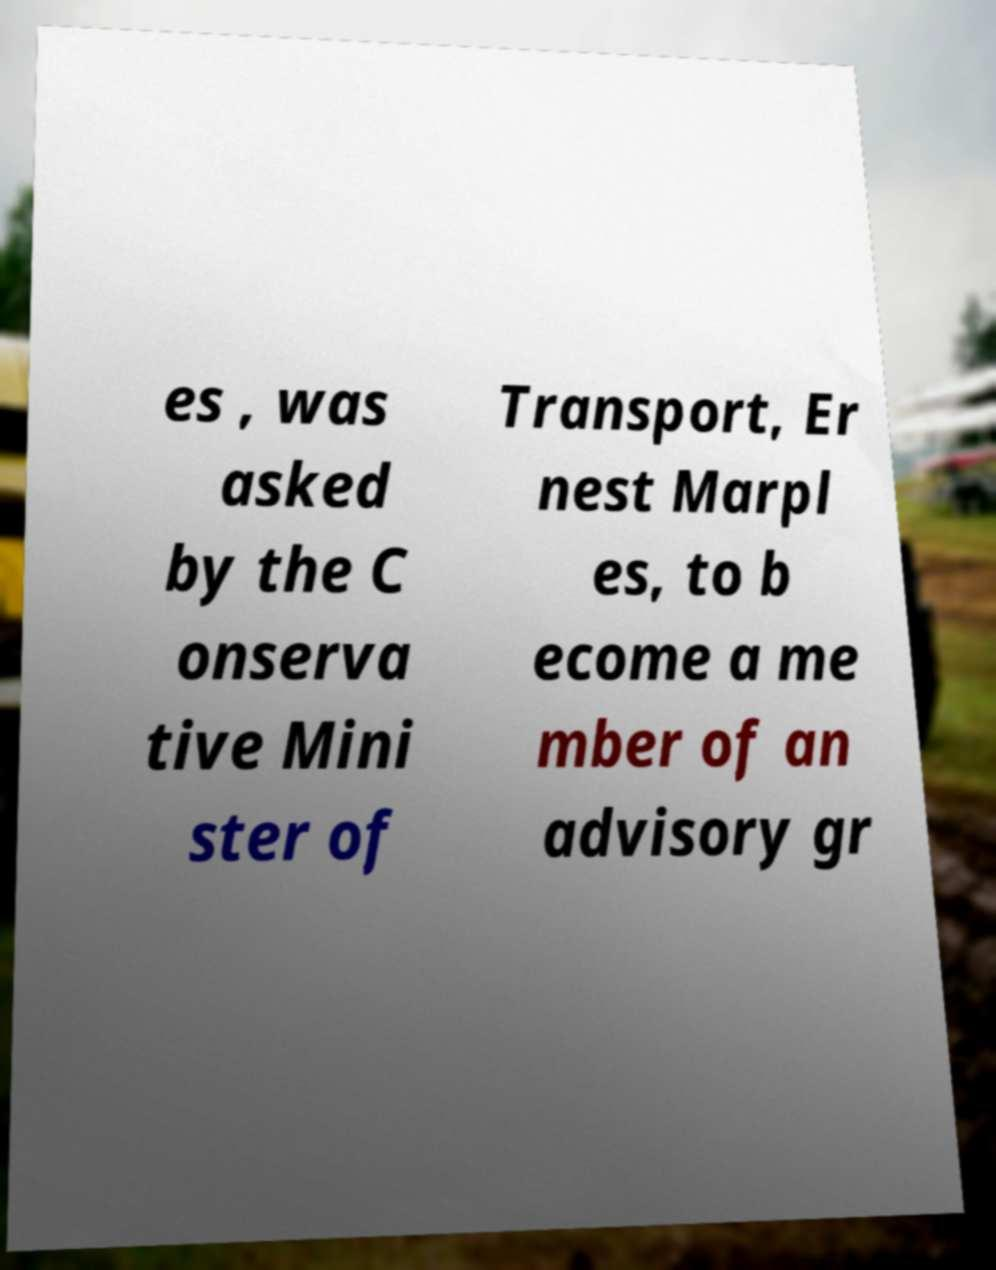Could you assist in decoding the text presented in this image and type it out clearly? es , was asked by the C onserva tive Mini ster of Transport, Er nest Marpl es, to b ecome a me mber of an advisory gr 